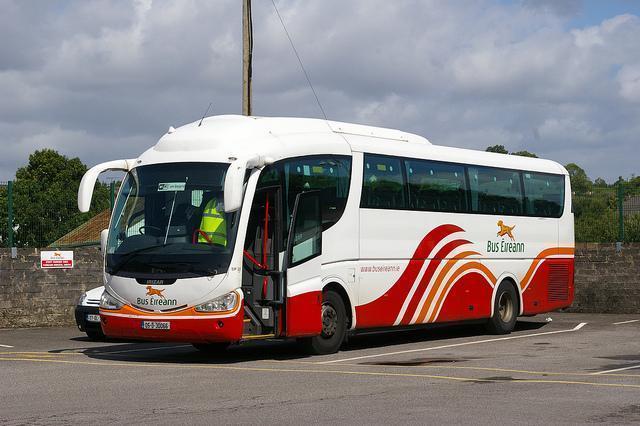Why is the man wearing a yellow vest?
Indicate the correct response and explain using: 'Answer: answer
Rationale: rationale.'
Options: Costume, disguise, visibility, fashion. Answer: visibility.
Rationale: He is wearing a safety vest 